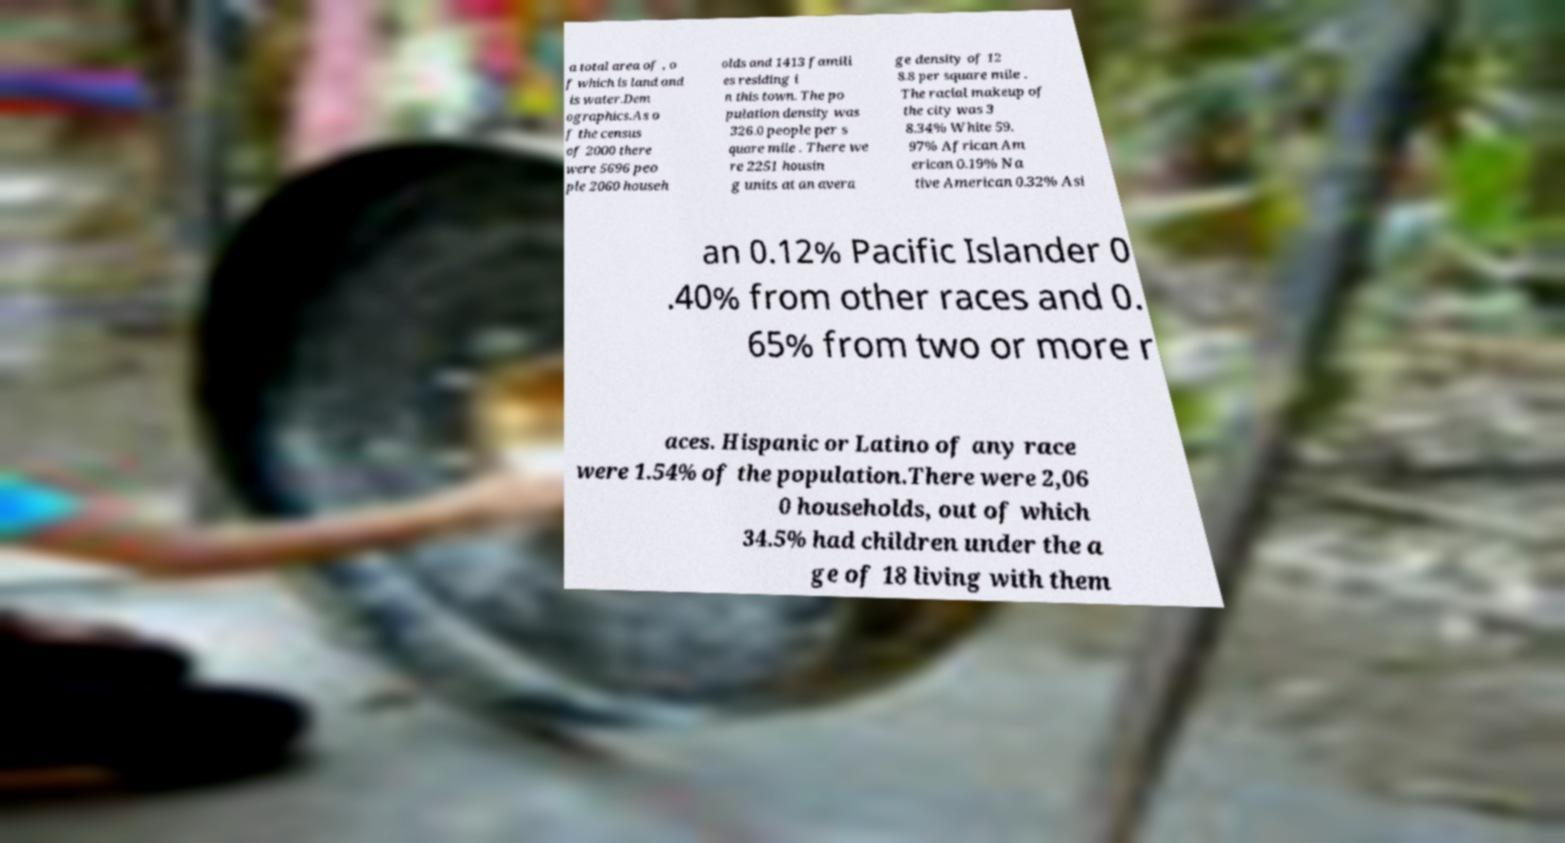There's text embedded in this image that I need extracted. Can you transcribe it verbatim? a total area of , o f which is land and is water.Dem ographics.As o f the census of 2000 there were 5696 peo ple 2060 househ olds and 1413 famili es residing i n this town. The po pulation density was 326.0 people per s quare mile . There we re 2251 housin g units at an avera ge density of 12 8.8 per square mile . The racial makeup of the city was 3 8.34% White 59. 97% African Am erican 0.19% Na tive American 0.32% Asi an 0.12% Pacific Islander 0 .40% from other races and 0. 65% from two or more r aces. Hispanic or Latino of any race were 1.54% of the population.There were 2,06 0 households, out of which 34.5% had children under the a ge of 18 living with them 